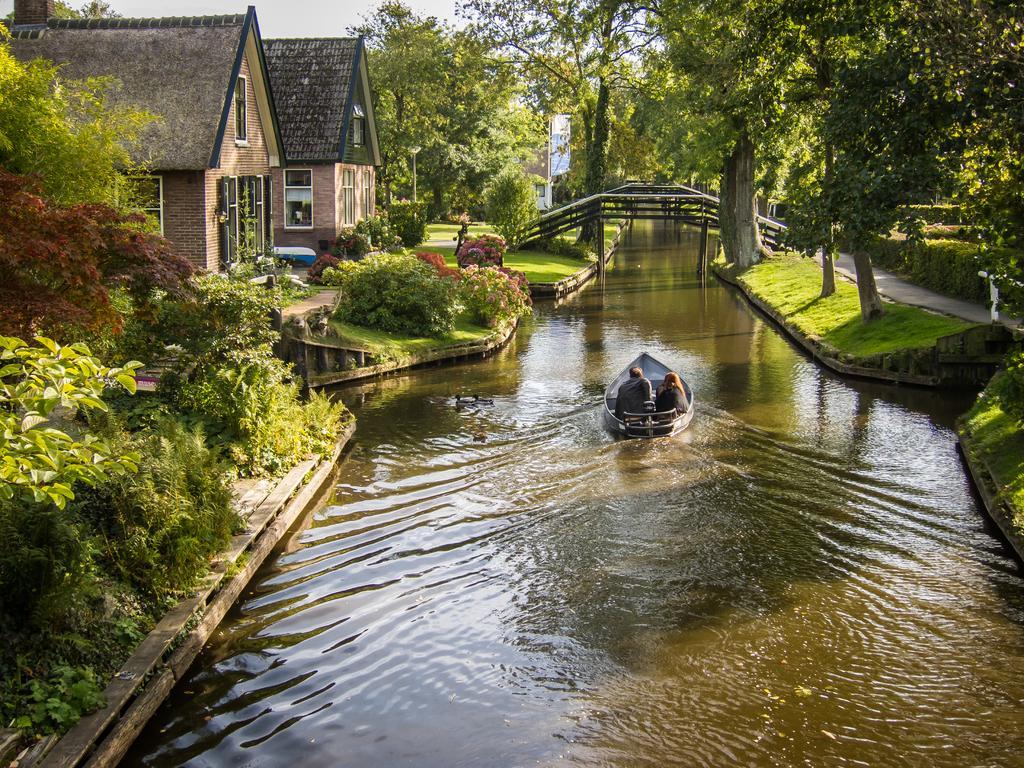Please provide a concise description of this image. In this image we can see a boat on the surface of water. We can see two people on the boat. On the left side of the image, we can see plants, trees, grass and buildings. At the top of the image, we can see the sky. On the right side of the image, we can see trees, grass, plants and the pathway. In the middle of the image, we can see wooden objects. 